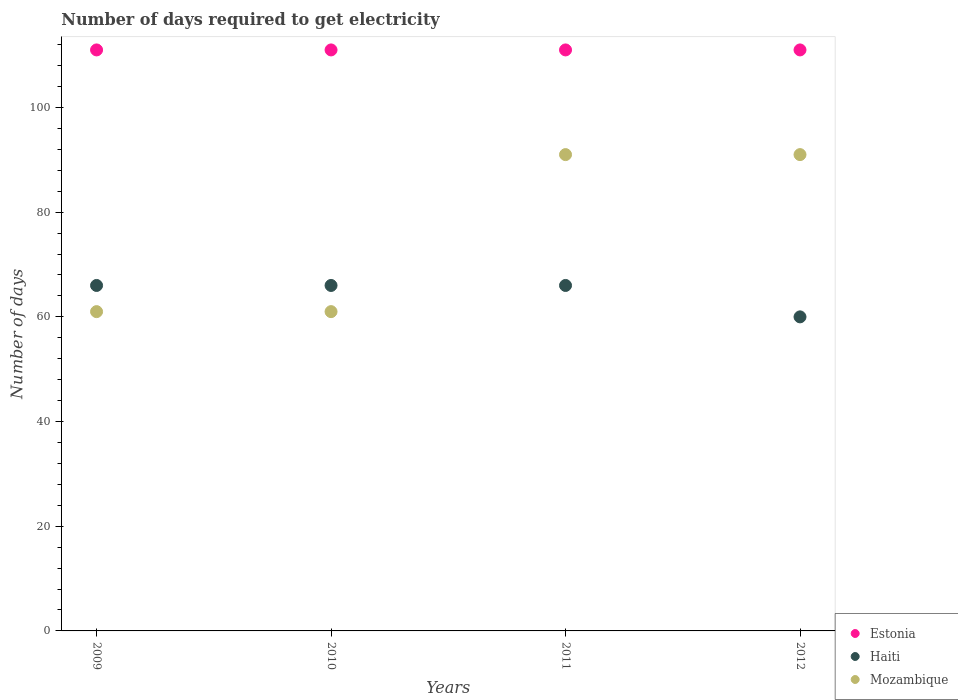How many different coloured dotlines are there?
Give a very brief answer. 3. Is the number of dotlines equal to the number of legend labels?
Provide a succinct answer. Yes. What is the number of days required to get electricity in in Estonia in 2012?
Provide a succinct answer. 111. Across all years, what is the maximum number of days required to get electricity in in Haiti?
Offer a terse response. 66. Across all years, what is the minimum number of days required to get electricity in in Haiti?
Provide a succinct answer. 60. In which year was the number of days required to get electricity in in Haiti maximum?
Offer a terse response. 2009. In which year was the number of days required to get electricity in in Haiti minimum?
Give a very brief answer. 2012. What is the total number of days required to get electricity in in Haiti in the graph?
Give a very brief answer. 258. What is the difference between the number of days required to get electricity in in Mozambique in 2011 and the number of days required to get electricity in in Haiti in 2010?
Offer a terse response. 25. In the year 2011, what is the difference between the number of days required to get electricity in in Estonia and number of days required to get electricity in in Mozambique?
Provide a succinct answer. 20. In how many years, is the number of days required to get electricity in in Mozambique greater than 100 days?
Give a very brief answer. 0. Is the difference between the number of days required to get electricity in in Estonia in 2009 and 2011 greater than the difference between the number of days required to get electricity in in Mozambique in 2009 and 2011?
Provide a succinct answer. Yes. What is the difference between the highest and the second highest number of days required to get electricity in in Estonia?
Your answer should be very brief. 0. Is the number of days required to get electricity in in Haiti strictly greater than the number of days required to get electricity in in Estonia over the years?
Your answer should be compact. No. Is the number of days required to get electricity in in Estonia strictly less than the number of days required to get electricity in in Mozambique over the years?
Ensure brevity in your answer.  No. What is the difference between two consecutive major ticks on the Y-axis?
Your answer should be compact. 20. Does the graph contain grids?
Keep it short and to the point. No. What is the title of the graph?
Your response must be concise. Number of days required to get electricity. Does "Ethiopia" appear as one of the legend labels in the graph?
Make the answer very short. No. What is the label or title of the Y-axis?
Your answer should be compact. Number of days. What is the Number of days of Estonia in 2009?
Your answer should be very brief. 111. What is the Number of days of Haiti in 2009?
Your response must be concise. 66. What is the Number of days in Estonia in 2010?
Your answer should be compact. 111. What is the Number of days of Haiti in 2010?
Your response must be concise. 66. What is the Number of days of Estonia in 2011?
Offer a very short reply. 111. What is the Number of days of Haiti in 2011?
Your answer should be very brief. 66. What is the Number of days of Mozambique in 2011?
Make the answer very short. 91. What is the Number of days in Estonia in 2012?
Offer a terse response. 111. What is the Number of days in Haiti in 2012?
Provide a short and direct response. 60. What is the Number of days in Mozambique in 2012?
Provide a succinct answer. 91. Across all years, what is the maximum Number of days in Estonia?
Provide a succinct answer. 111. Across all years, what is the maximum Number of days of Mozambique?
Offer a very short reply. 91. Across all years, what is the minimum Number of days of Estonia?
Your answer should be compact. 111. Across all years, what is the minimum Number of days in Haiti?
Your response must be concise. 60. What is the total Number of days in Estonia in the graph?
Ensure brevity in your answer.  444. What is the total Number of days of Haiti in the graph?
Your answer should be compact. 258. What is the total Number of days in Mozambique in the graph?
Offer a terse response. 304. What is the difference between the Number of days of Haiti in 2009 and that in 2010?
Provide a short and direct response. 0. What is the difference between the Number of days in Estonia in 2009 and that in 2011?
Provide a short and direct response. 0. What is the difference between the Number of days in Haiti in 2009 and that in 2011?
Give a very brief answer. 0. What is the difference between the Number of days of Estonia in 2009 and that in 2012?
Make the answer very short. 0. What is the difference between the Number of days in Haiti in 2009 and that in 2012?
Your answer should be compact. 6. What is the difference between the Number of days of Mozambique in 2009 and that in 2012?
Ensure brevity in your answer.  -30. What is the difference between the Number of days of Haiti in 2010 and that in 2011?
Provide a short and direct response. 0. What is the difference between the Number of days of Mozambique in 2010 and that in 2011?
Ensure brevity in your answer.  -30. What is the difference between the Number of days in Haiti in 2010 and that in 2012?
Make the answer very short. 6. What is the difference between the Number of days in Estonia in 2011 and that in 2012?
Offer a terse response. 0. What is the difference between the Number of days of Haiti in 2011 and that in 2012?
Give a very brief answer. 6. What is the difference between the Number of days in Estonia in 2009 and the Number of days in Haiti in 2010?
Give a very brief answer. 45. What is the difference between the Number of days in Estonia in 2009 and the Number of days in Mozambique in 2010?
Provide a succinct answer. 50. What is the difference between the Number of days in Estonia in 2009 and the Number of days in Haiti in 2011?
Your answer should be very brief. 45. What is the difference between the Number of days of Estonia in 2009 and the Number of days of Haiti in 2012?
Ensure brevity in your answer.  51. What is the difference between the Number of days of Haiti in 2009 and the Number of days of Mozambique in 2012?
Make the answer very short. -25. What is the difference between the Number of days in Estonia in 2010 and the Number of days in Mozambique in 2011?
Your response must be concise. 20. What is the difference between the Number of days of Haiti in 2010 and the Number of days of Mozambique in 2011?
Provide a succinct answer. -25. What is the difference between the Number of days of Haiti in 2010 and the Number of days of Mozambique in 2012?
Your response must be concise. -25. What is the difference between the Number of days of Estonia in 2011 and the Number of days of Mozambique in 2012?
Your answer should be very brief. 20. What is the difference between the Number of days in Haiti in 2011 and the Number of days in Mozambique in 2012?
Offer a terse response. -25. What is the average Number of days of Estonia per year?
Provide a succinct answer. 111. What is the average Number of days in Haiti per year?
Provide a succinct answer. 64.5. What is the average Number of days in Mozambique per year?
Your response must be concise. 76. In the year 2009, what is the difference between the Number of days in Haiti and Number of days in Mozambique?
Give a very brief answer. 5. In the year 2010, what is the difference between the Number of days in Estonia and Number of days in Haiti?
Keep it short and to the point. 45. In the year 2010, what is the difference between the Number of days of Estonia and Number of days of Mozambique?
Provide a succinct answer. 50. In the year 2010, what is the difference between the Number of days in Haiti and Number of days in Mozambique?
Your answer should be very brief. 5. In the year 2011, what is the difference between the Number of days in Estonia and Number of days in Haiti?
Provide a succinct answer. 45. In the year 2011, what is the difference between the Number of days in Estonia and Number of days in Mozambique?
Your answer should be compact. 20. In the year 2012, what is the difference between the Number of days of Estonia and Number of days of Mozambique?
Give a very brief answer. 20. In the year 2012, what is the difference between the Number of days in Haiti and Number of days in Mozambique?
Ensure brevity in your answer.  -31. What is the ratio of the Number of days in Estonia in 2009 to that in 2010?
Provide a short and direct response. 1. What is the ratio of the Number of days of Estonia in 2009 to that in 2011?
Provide a short and direct response. 1. What is the ratio of the Number of days of Mozambique in 2009 to that in 2011?
Provide a succinct answer. 0.67. What is the ratio of the Number of days in Mozambique in 2009 to that in 2012?
Ensure brevity in your answer.  0.67. What is the ratio of the Number of days in Haiti in 2010 to that in 2011?
Keep it short and to the point. 1. What is the ratio of the Number of days in Mozambique in 2010 to that in 2011?
Keep it short and to the point. 0.67. What is the ratio of the Number of days in Estonia in 2010 to that in 2012?
Offer a very short reply. 1. What is the ratio of the Number of days of Haiti in 2010 to that in 2012?
Your answer should be compact. 1.1. What is the ratio of the Number of days in Mozambique in 2010 to that in 2012?
Offer a terse response. 0.67. What is the ratio of the Number of days of Estonia in 2011 to that in 2012?
Keep it short and to the point. 1. What is the ratio of the Number of days in Haiti in 2011 to that in 2012?
Your answer should be very brief. 1.1. What is the difference between the highest and the lowest Number of days in Estonia?
Your answer should be very brief. 0. What is the difference between the highest and the lowest Number of days in Mozambique?
Provide a short and direct response. 30. 